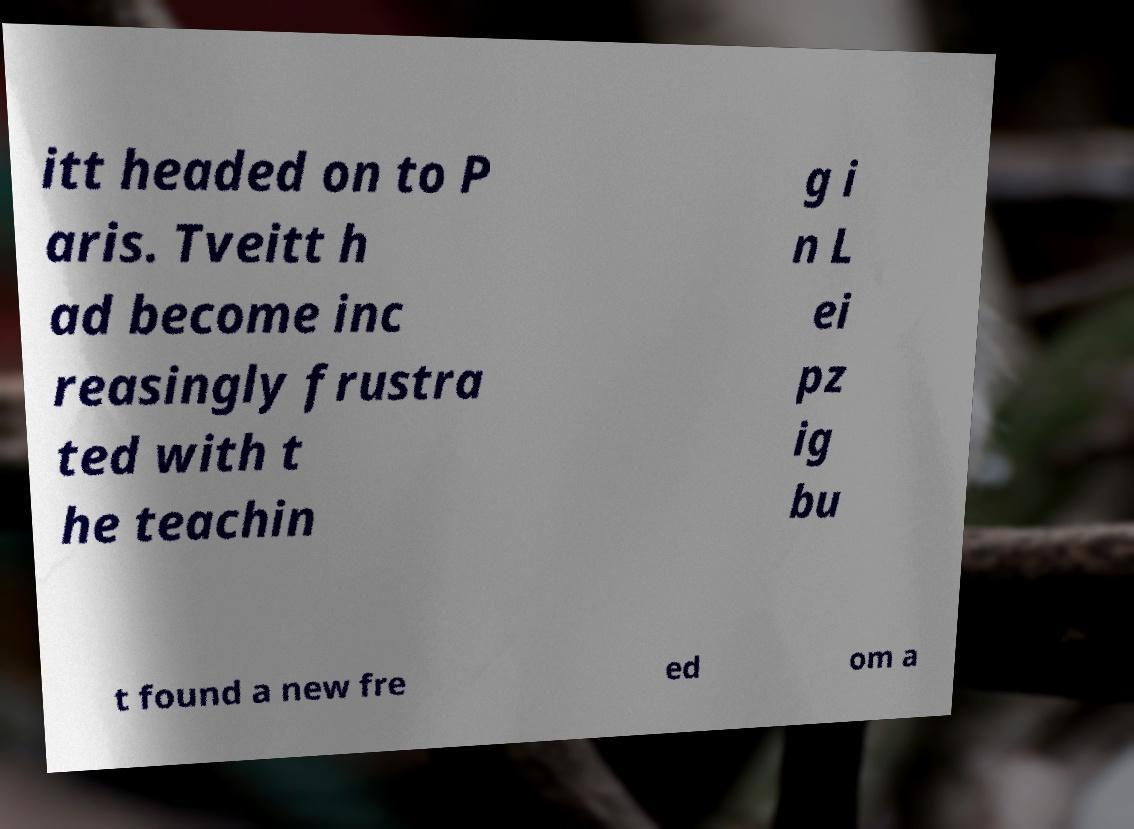Could you assist in decoding the text presented in this image and type it out clearly? itt headed on to P aris. Tveitt h ad become inc reasingly frustra ted with t he teachin g i n L ei pz ig bu t found a new fre ed om a 